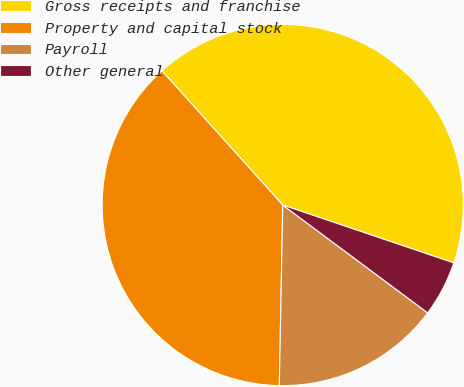<chart> <loc_0><loc_0><loc_500><loc_500><pie_chart><fcel>Gross receipts and franchise<fcel>Property and capital stock<fcel>Payroll<fcel>Other general<nl><fcel>41.86%<fcel>38.03%<fcel>15.12%<fcel>4.99%<nl></chart> 